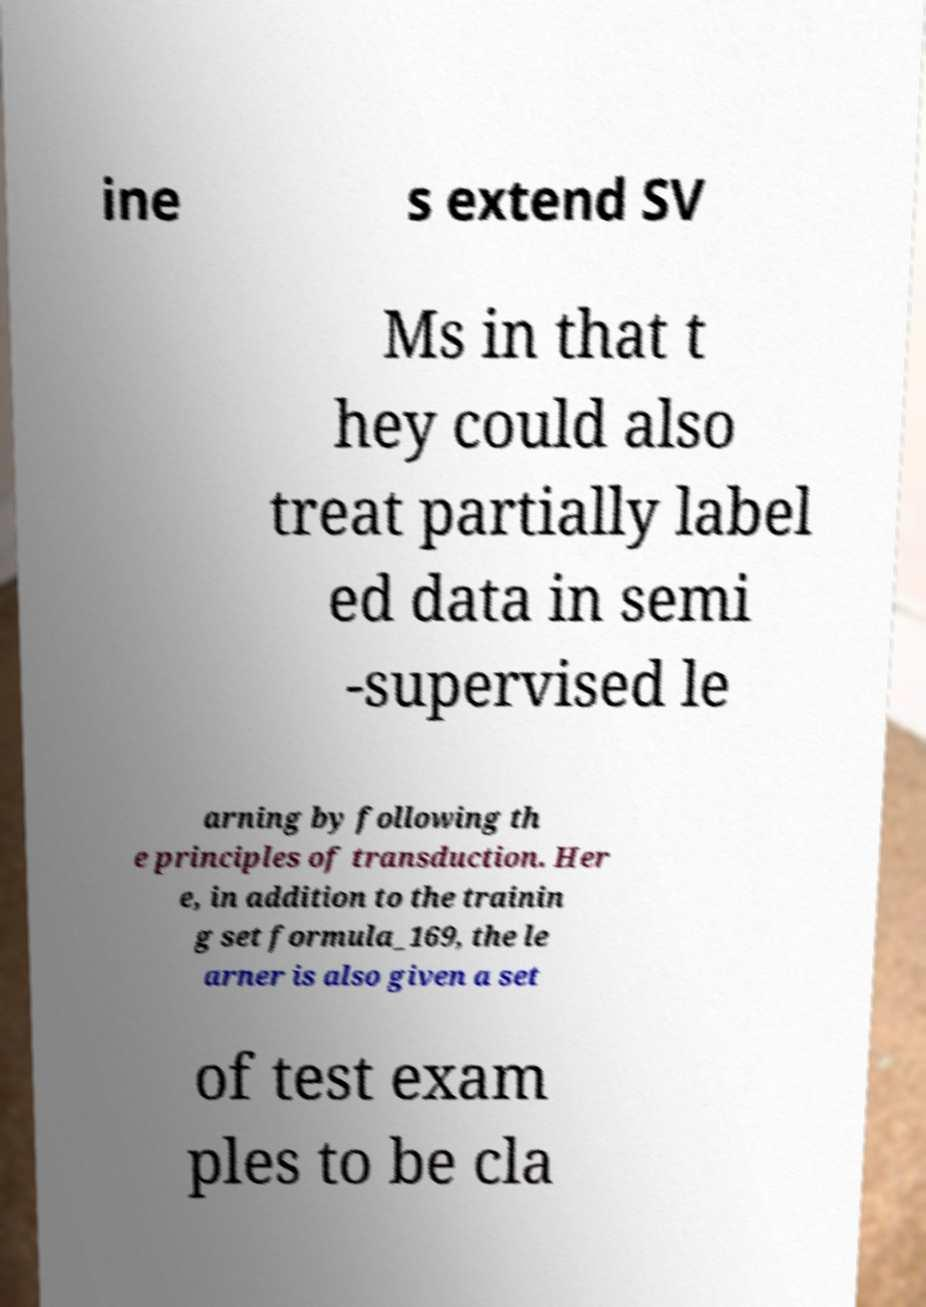Please identify and transcribe the text found in this image. ine s extend SV Ms in that t hey could also treat partially label ed data in semi -supervised le arning by following th e principles of transduction. Her e, in addition to the trainin g set formula_169, the le arner is also given a set of test exam ples to be cla 